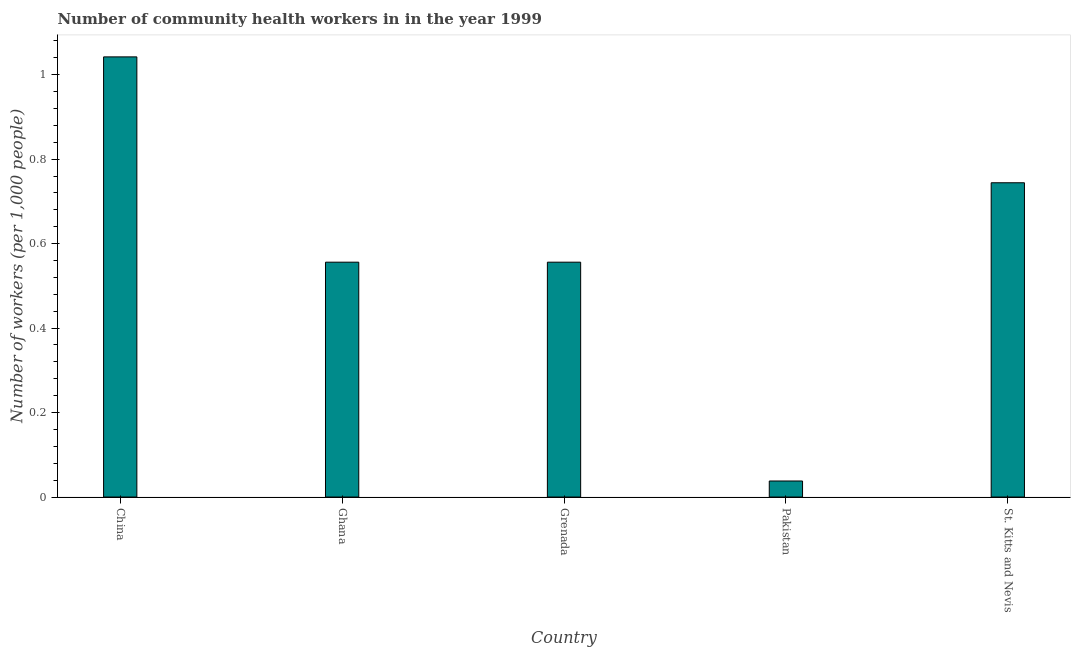Does the graph contain any zero values?
Your answer should be compact. No. What is the title of the graph?
Offer a very short reply. Number of community health workers in in the year 1999. What is the label or title of the Y-axis?
Your answer should be very brief. Number of workers (per 1,0 people). What is the number of community health workers in Pakistan?
Your answer should be compact. 0.04. Across all countries, what is the maximum number of community health workers?
Your response must be concise. 1.04. Across all countries, what is the minimum number of community health workers?
Your answer should be compact. 0.04. In which country was the number of community health workers maximum?
Offer a terse response. China. What is the sum of the number of community health workers?
Give a very brief answer. 2.94. What is the difference between the number of community health workers in Pakistan and St. Kitts and Nevis?
Your answer should be very brief. -0.71. What is the average number of community health workers per country?
Offer a very short reply. 0.59. What is the median number of community health workers?
Make the answer very short. 0.56. What is the ratio of the number of community health workers in China to that in Grenada?
Your answer should be very brief. 1.87. Is the number of community health workers in Ghana less than that in Grenada?
Make the answer very short. No. Is the difference between the number of community health workers in Ghana and St. Kitts and Nevis greater than the difference between any two countries?
Your answer should be compact. No. What is the difference between the highest and the second highest number of community health workers?
Give a very brief answer. 0.3. How many bars are there?
Offer a terse response. 5. What is the difference between two consecutive major ticks on the Y-axis?
Provide a succinct answer. 0.2. Are the values on the major ticks of Y-axis written in scientific E-notation?
Your answer should be very brief. No. What is the Number of workers (per 1,000 people) in China?
Provide a succinct answer. 1.04. What is the Number of workers (per 1,000 people) of Ghana?
Your response must be concise. 0.56. What is the Number of workers (per 1,000 people) of Grenada?
Ensure brevity in your answer.  0.56. What is the Number of workers (per 1,000 people) in Pakistan?
Your answer should be very brief. 0.04. What is the Number of workers (per 1,000 people) in St. Kitts and Nevis?
Keep it short and to the point. 0.74. What is the difference between the Number of workers (per 1,000 people) in China and Ghana?
Ensure brevity in your answer.  0.49. What is the difference between the Number of workers (per 1,000 people) in China and Grenada?
Provide a succinct answer. 0.49. What is the difference between the Number of workers (per 1,000 people) in China and Pakistan?
Offer a very short reply. 1. What is the difference between the Number of workers (per 1,000 people) in China and St. Kitts and Nevis?
Provide a short and direct response. 0.3. What is the difference between the Number of workers (per 1,000 people) in Ghana and Grenada?
Ensure brevity in your answer.  0. What is the difference between the Number of workers (per 1,000 people) in Ghana and Pakistan?
Offer a very short reply. 0.52. What is the difference between the Number of workers (per 1,000 people) in Ghana and St. Kitts and Nevis?
Make the answer very short. -0.19. What is the difference between the Number of workers (per 1,000 people) in Grenada and Pakistan?
Provide a short and direct response. 0.52. What is the difference between the Number of workers (per 1,000 people) in Grenada and St. Kitts and Nevis?
Offer a very short reply. -0.19. What is the difference between the Number of workers (per 1,000 people) in Pakistan and St. Kitts and Nevis?
Offer a terse response. -0.71. What is the ratio of the Number of workers (per 1,000 people) in China to that in Ghana?
Offer a terse response. 1.87. What is the ratio of the Number of workers (per 1,000 people) in China to that in Grenada?
Give a very brief answer. 1.87. What is the ratio of the Number of workers (per 1,000 people) in China to that in Pakistan?
Ensure brevity in your answer.  27.42. What is the ratio of the Number of workers (per 1,000 people) in China to that in St. Kitts and Nevis?
Ensure brevity in your answer.  1.4. What is the ratio of the Number of workers (per 1,000 people) in Ghana to that in Grenada?
Provide a short and direct response. 1. What is the ratio of the Number of workers (per 1,000 people) in Ghana to that in Pakistan?
Keep it short and to the point. 14.63. What is the ratio of the Number of workers (per 1,000 people) in Ghana to that in St. Kitts and Nevis?
Keep it short and to the point. 0.75. What is the ratio of the Number of workers (per 1,000 people) in Grenada to that in Pakistan?
Keep it short and to the point. 14.63. What is the ratio of the Number of workers (per 1,000 people) in Grenada to that in St. Kitts and Nevis?
Your answer should be very brief. 0.75. What is the ratio of the Number of workers (per 1,000 people) in Pakistan to that in St. Kitts and Nevis?
Make the answer very short. 0.05. 